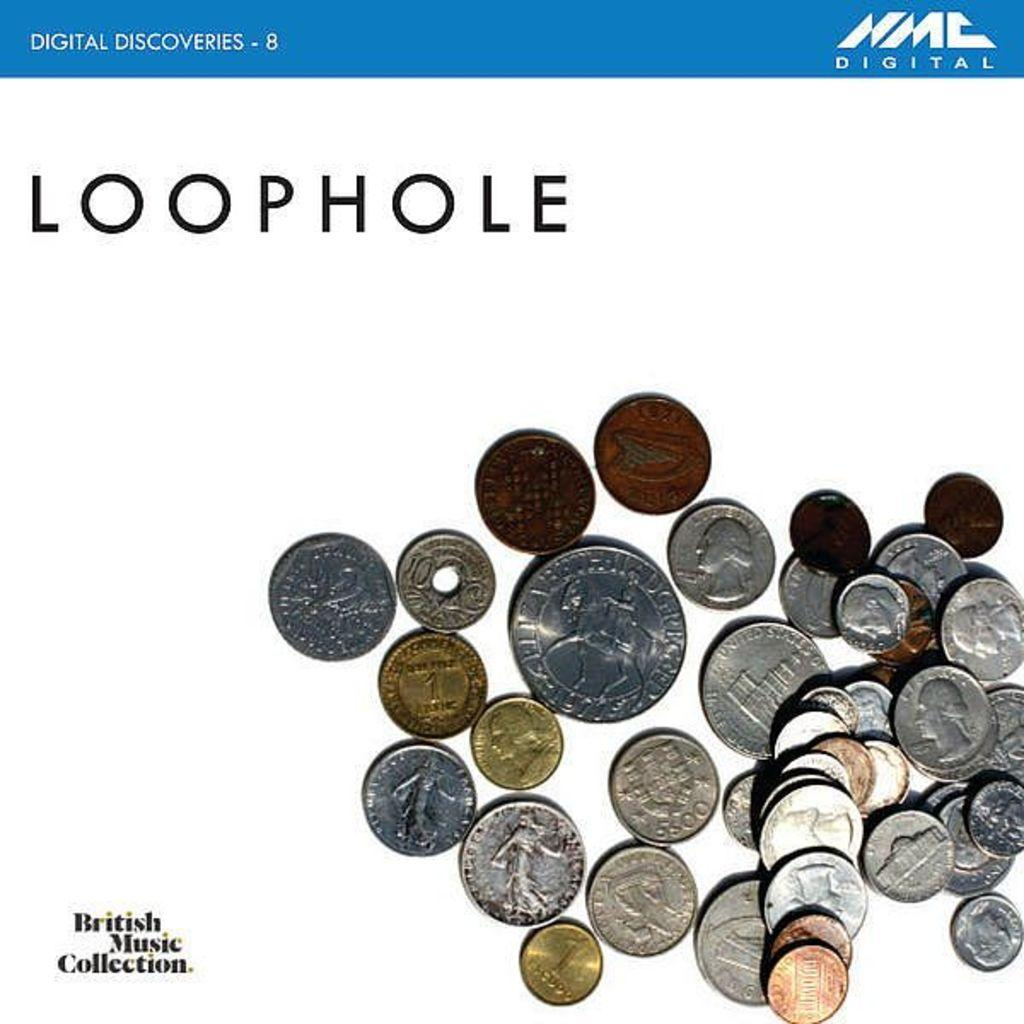<image>
Create a compact narrative representing the image presented. A pile of gold and silver change with British Music Collection written next to the coins. 